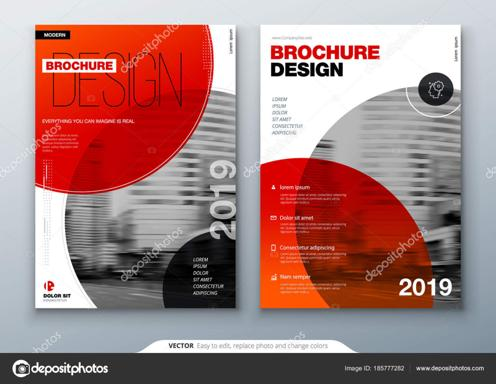What are the dimensions of this brochure, and what does this mean for content placement? The brochure appears to be in a standard A4 format, which is approximately 210 x 297 mm. This size is versatile for detailed content placement, allowing ample space for text, images, and graphics while maintaining a clean, readable layout that is easy to handle and distribute. 